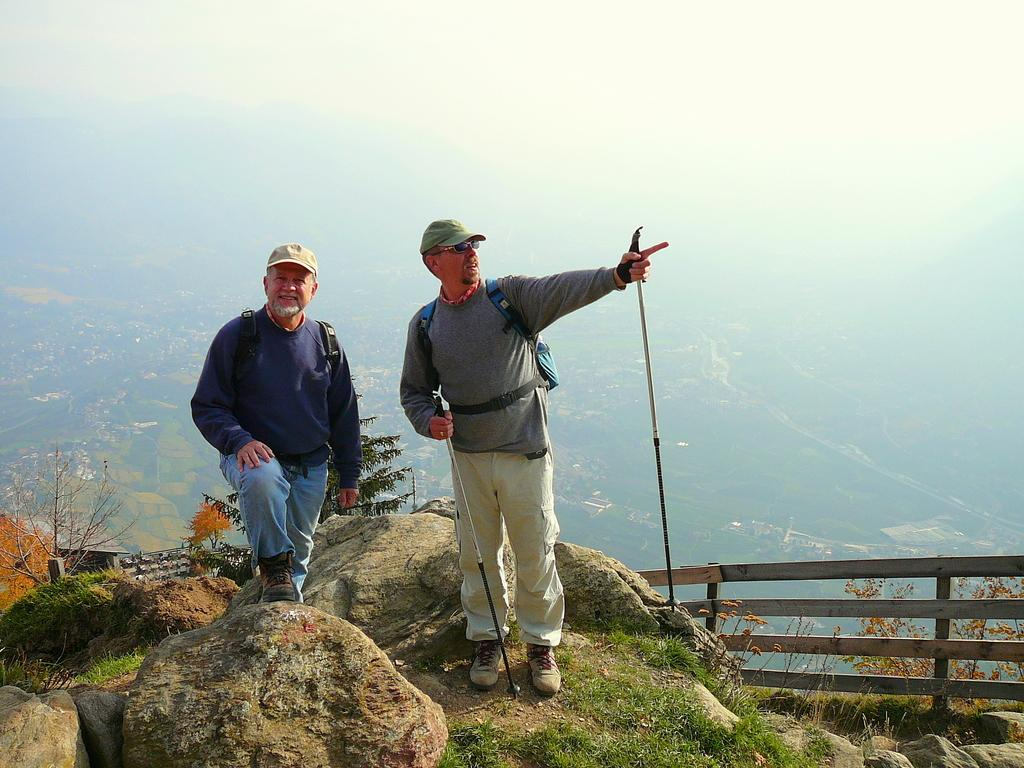How many men are in the image? There are two men in the image. What are the men wearing on their backs? Both men are wearing backpacks. What are the men wearing on their heads? Both men are wearing caps. What is the right side man holding in the image? The right side man is holding sticks. What can be seen in the background of the image? There is a fence and trees in the image. What type of bait is the man on the left side using to catch fish in the image? There is no fishing or bait present in the image; both men are holding sticks. How many rolls can be seen on the ground in the image? There are no rolls visible on the ground in the image. 